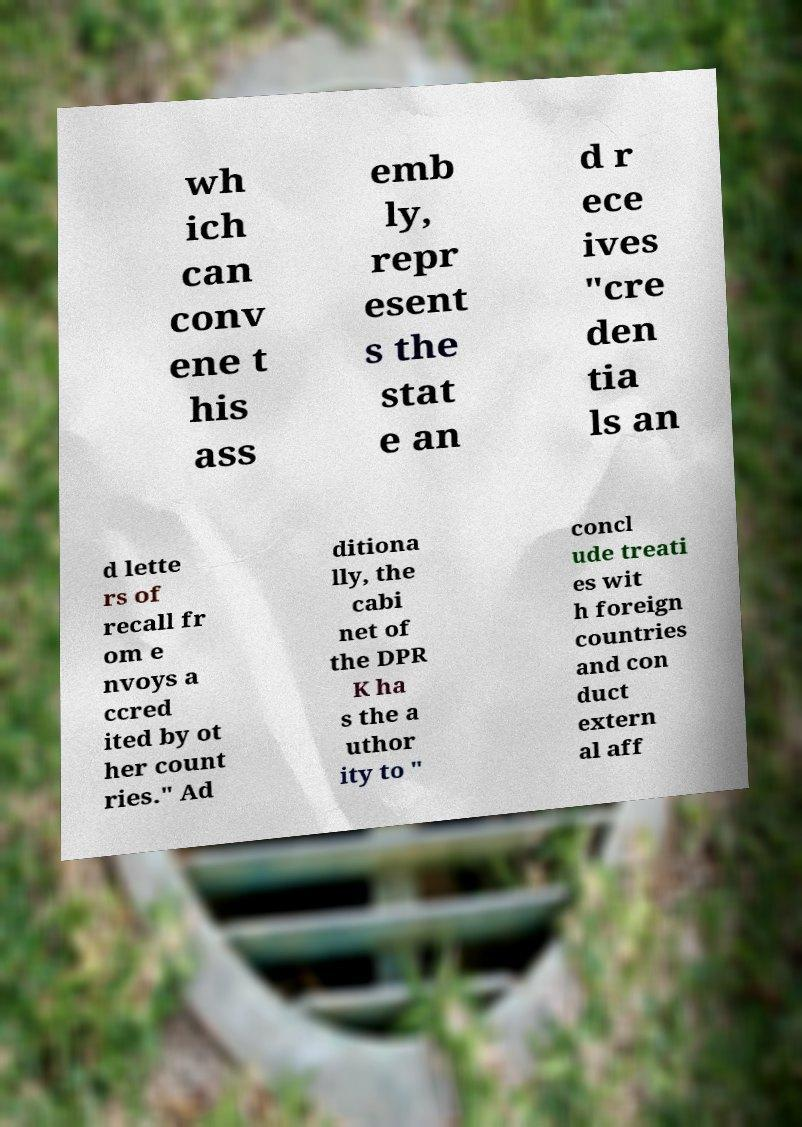I need the written content from this picture converted into text. Can you do that? wh ich can conv ene t his ass emb ly, repr esent s the stat e an d r ece ives "cre den tia ls an d lette rs of recall fr om e nvoys a ccred ited by ot her count ries." Ad ditiona lly, the cabi net of the DPR K ha s the a uthor ity to " concl ude treati es wit h foreign countries and con duct extern al aff 